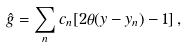Convert formula to latex. <formula><loc_0><loc_0><loc_500><loc_500>\hat { g } = \sum _ { n } c _ { n } [ 2 \theta ( y - y _ { n } ) - 1 ] \, ,</formula> 